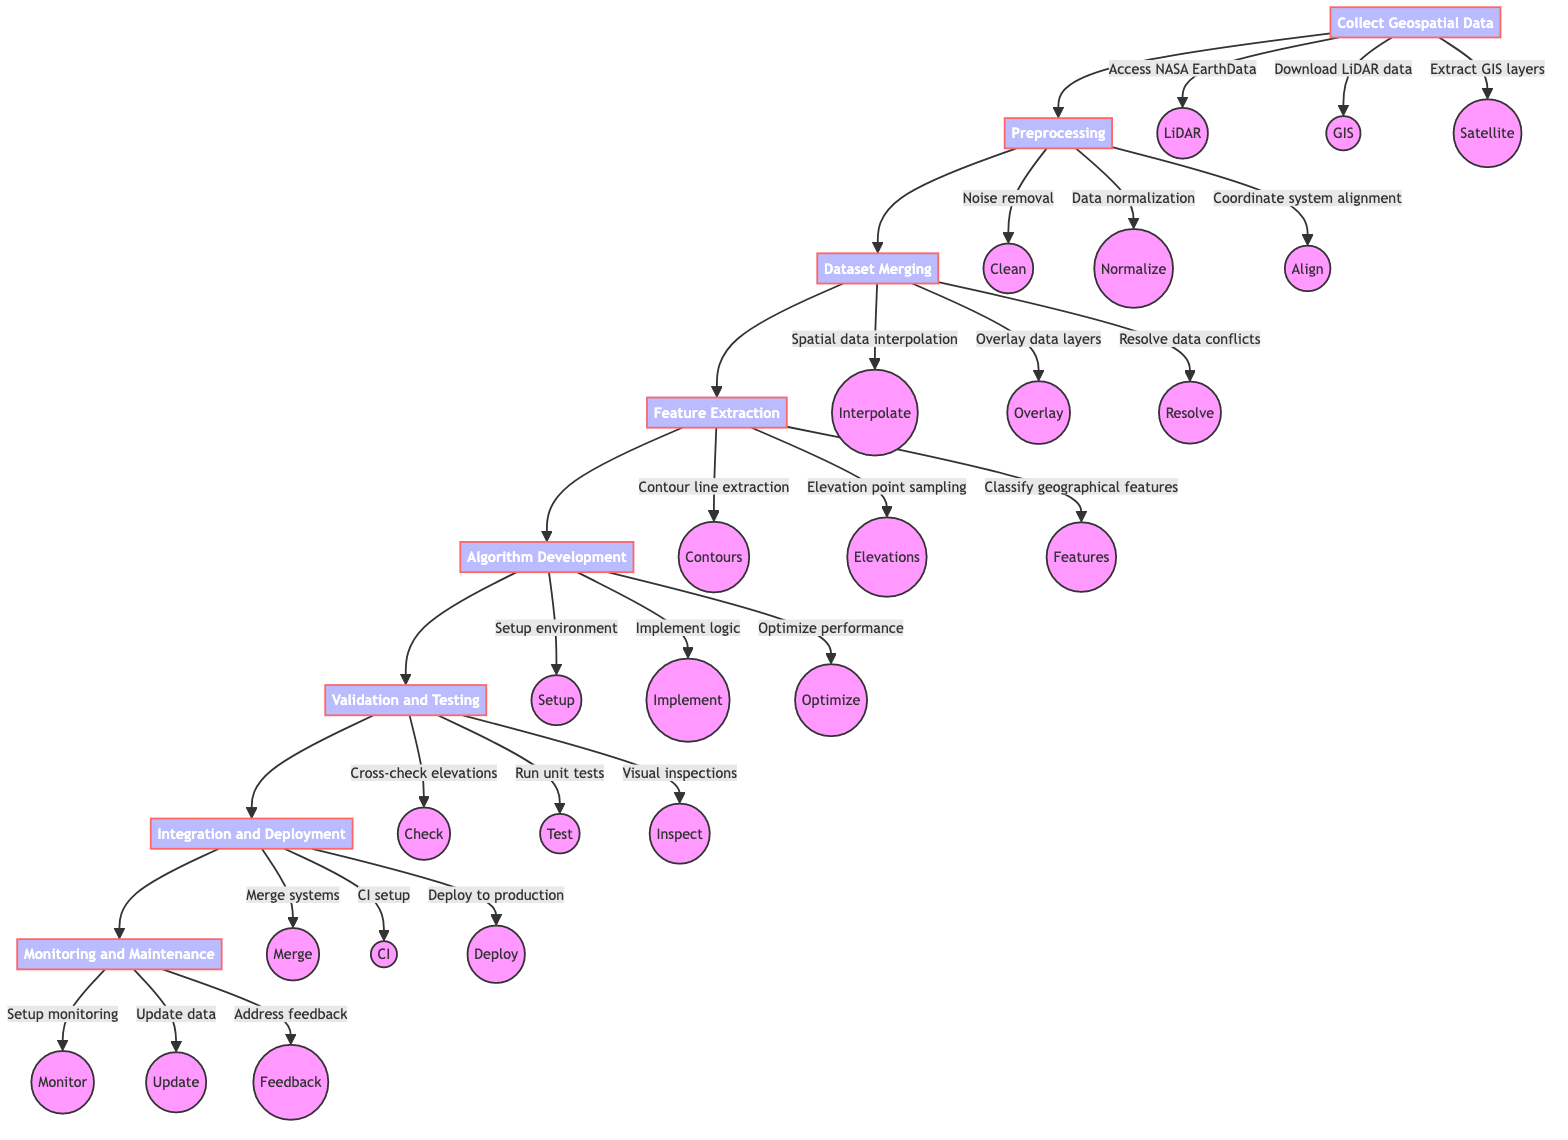What is the first step in the workflow? The diagram indicates that the first step in the workflow is "Collect Geospatial Data," which is the starting point before any preprocessing occurs.
Answer: Collect Geospatial Data How many actions are taken during the preprocessing step? In the "Preprocessing" step, there are three actions listed: noise removal, data normalization, and coordinate system alignment; therefore, the total number of actions is three.
Answer: 3 What node directly follows dataset merging? The diagram shows that "Feature Extraction" is the next step after "Dataset Merging," meaning it directly follows this node in the process flow.
Answer: Feature Extraction Name one action that occurs during the validation and testing phase. The "Validation and Testing" phase includes various actions, one of which is "Run unit tests," responding to the prompt for a specific action from this step.
Answer: Run unit tests What happens after the algorithm development step? The step that follows "Algorithm Development" in the diagram is "Validation and Testing," indicating what comes next in the workflow sequence.
Answer: Validation and Testing How many main workflow steps are there in total? By counting the steps outlined in the flowchart, there are eight main workflow steps listed, including Collect Geospatial Data, Preprocessing, Dataset Merging, Feature Extraction, Algorithm Development, Validation and Testing, Integration and Deployment, and Monitoring and Maintenance.
Answer: 8 Which action is part of the integration and deployment phase? In the "Integration and Deployment" phase, one of the actions is "Deploy to production environment," showcasing a specific task conducted during this stage.
Answer: Deploy to production environment What is the last step of the workflow? The diagram clearly specifies that "Monitoring and Maintenance" is the final step in the workflow, as there are no additional steps that follow it.
Answer: Monitoring and Maintenance What type of data is accessed in the collect geospatial data step? The "Collect Geospatial Data" step mentions accessing various types of data, including "NASA EarthData," which is one of the specifically referenced data sources.
Answer: NASA EarthData 